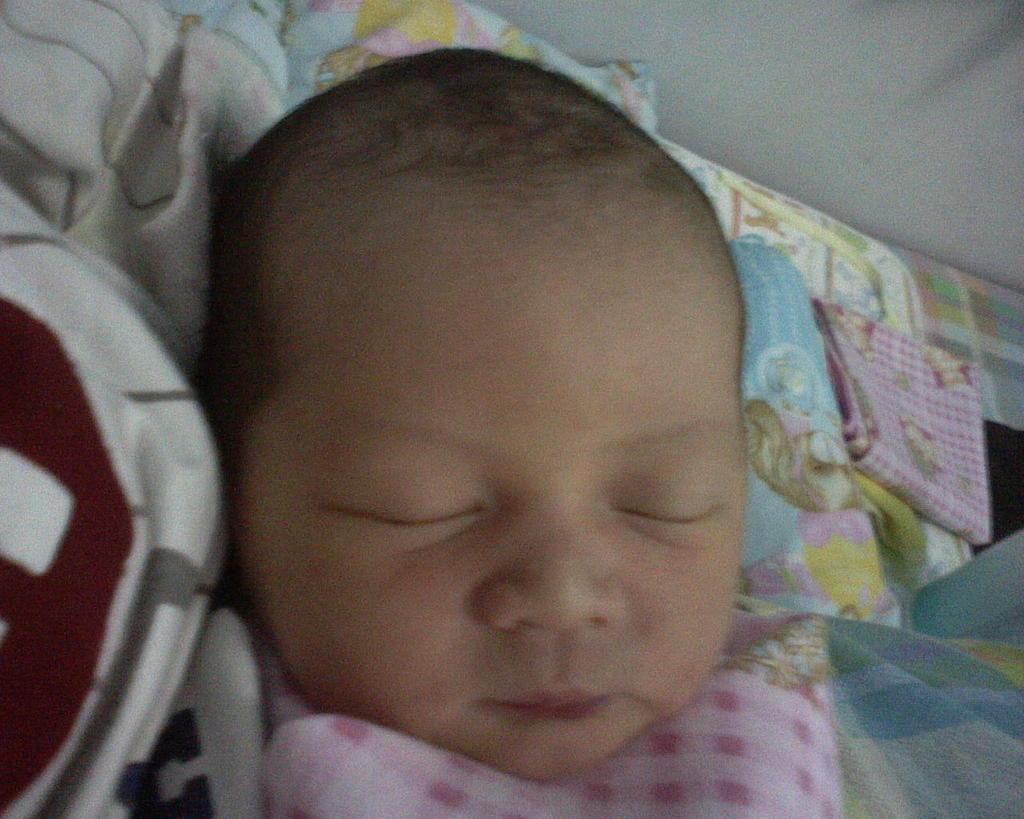How would you summarize this image in a sentence or two? In this image I can see a baby is laying on a sleeping bag. On the right side there is a cloth on a bed. In the top right-hand corner there is a wall. 